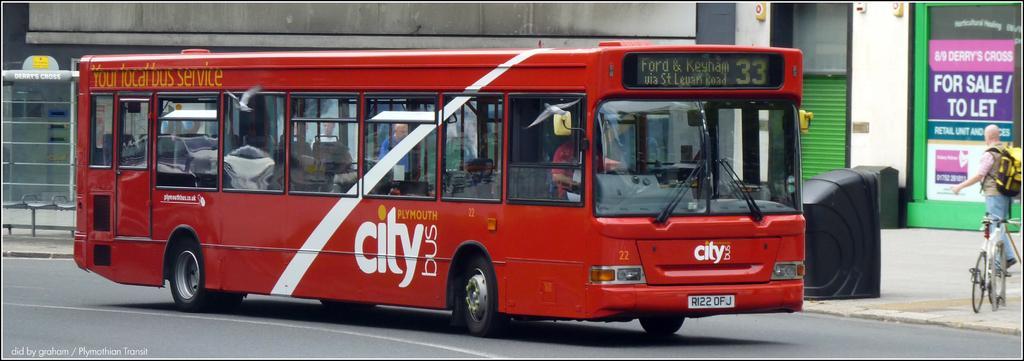In one or two sentences, can you explain what this image depicts? In this image in the foreground we can see a bus on the road and on the right, we can see a person standing. 